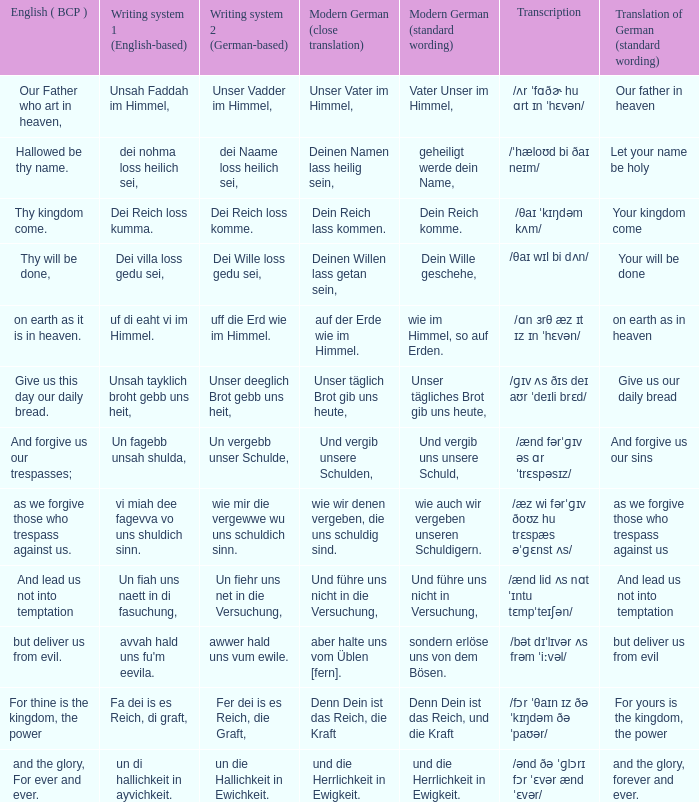What is the modern german standard wording for the german based writing system 2 phrase "wie mir die vergewwe wu uns schuldich sinn."? Wie auch wir vergeben unseren schuldigern. 